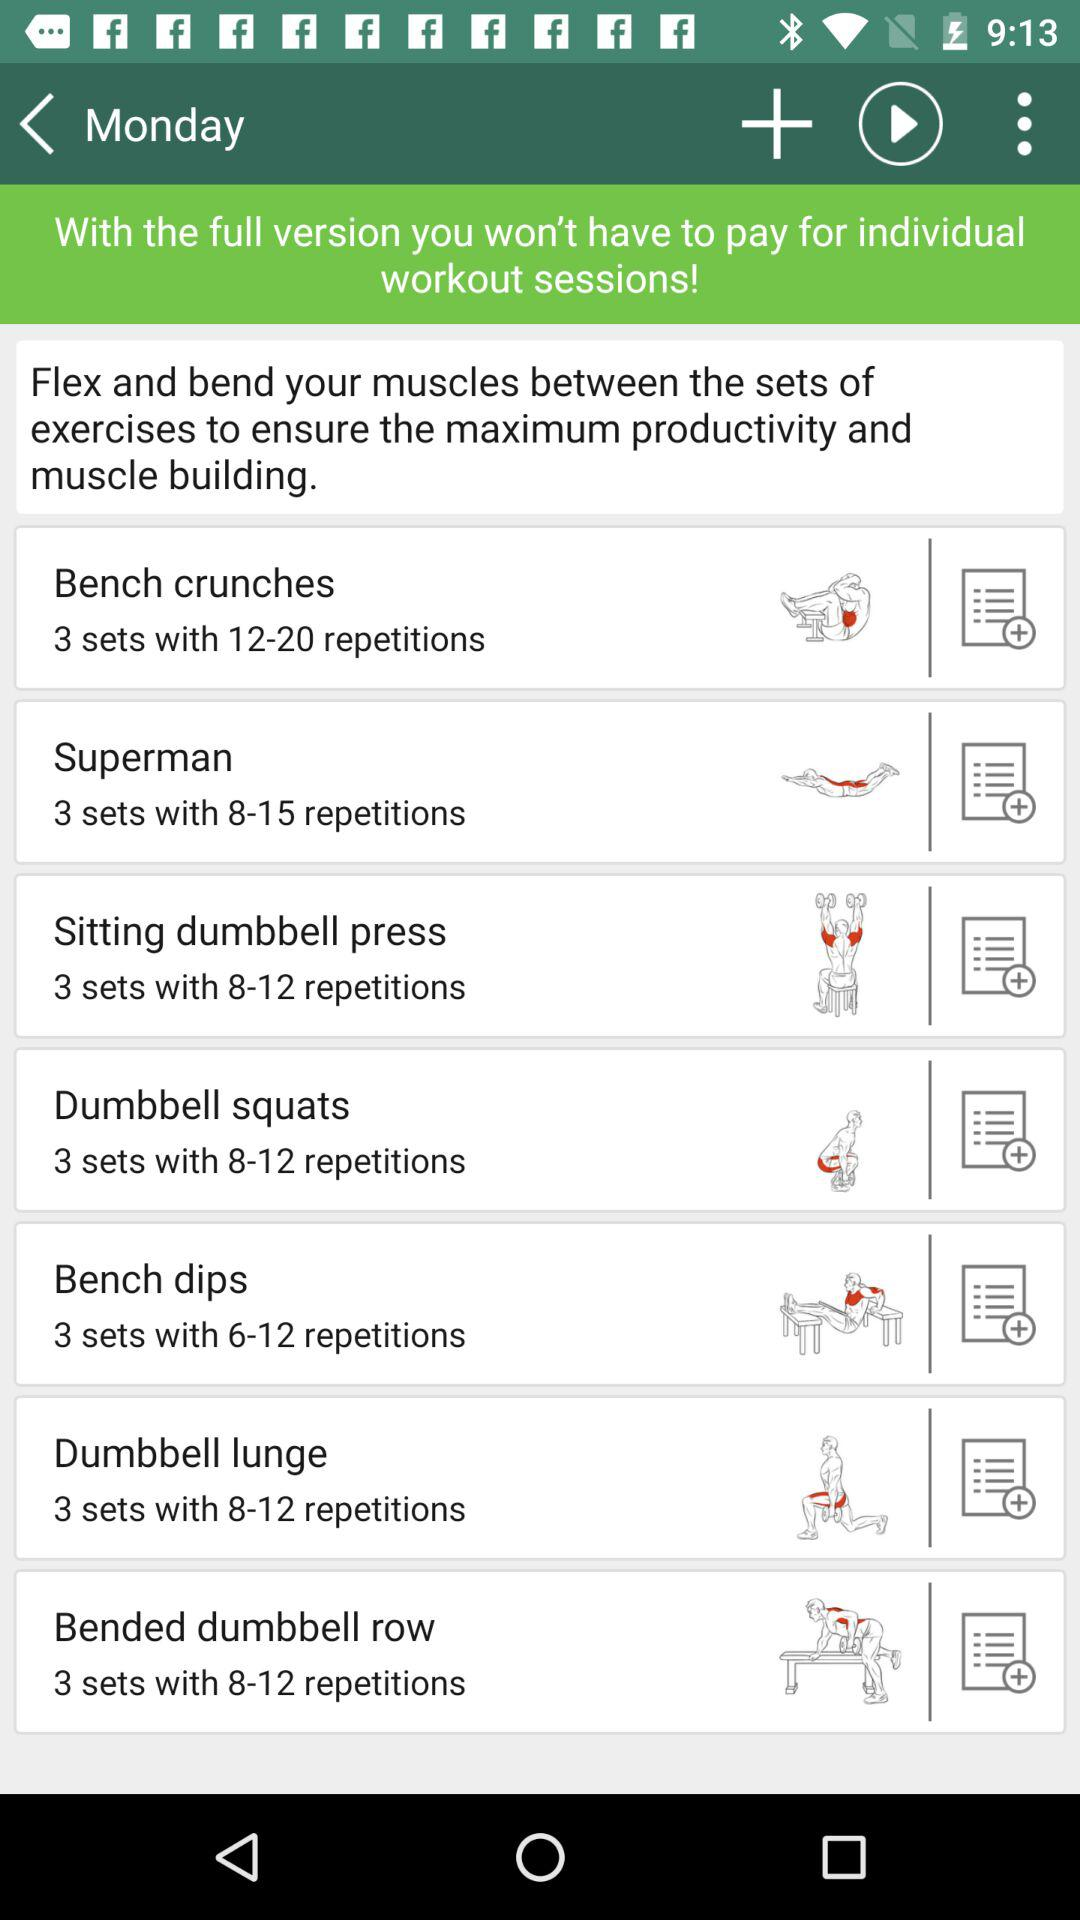On what day is the exercise scheduled? The day is "Monday". 